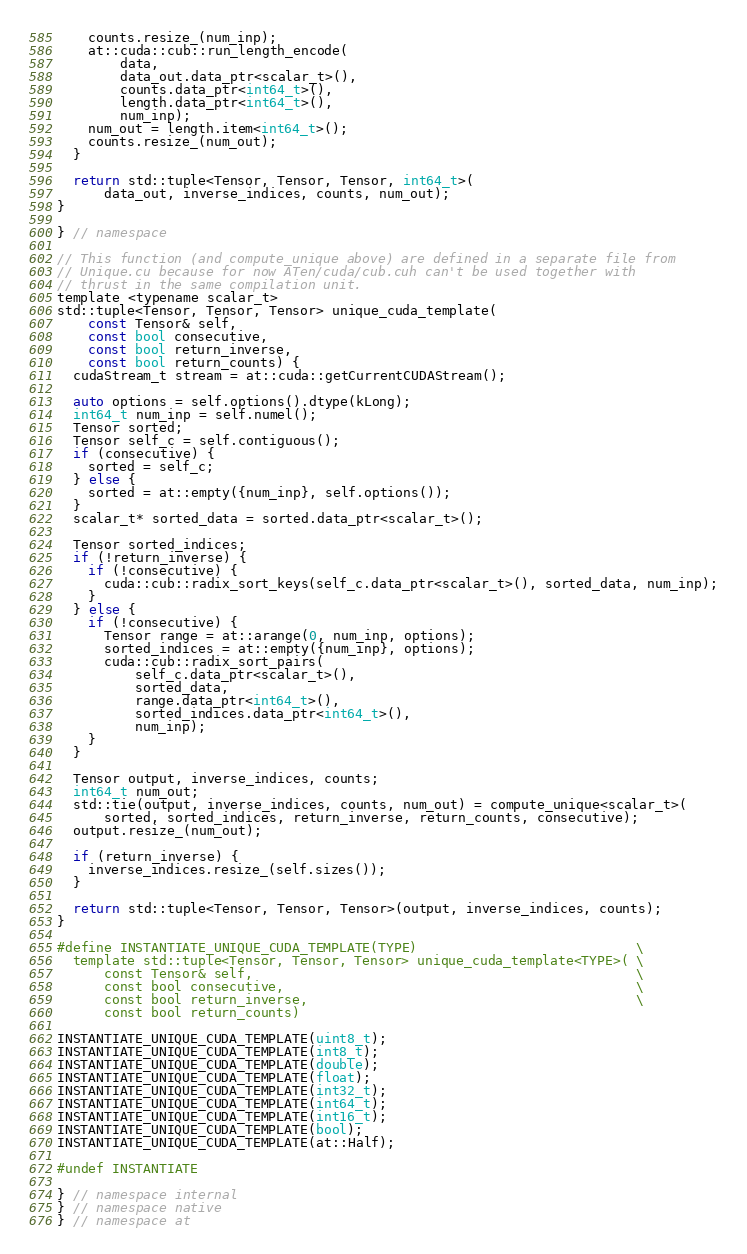Convert code to text. <code><loc_0><loc_0><loc_500><loc_500><_Cuda_>    counts.resize_(num_inp);
    at::cuda::cub::run_length_encode(
        data,
        data_out.data_ptr<scalar_t>(),
        counts.data_ptr<int64_t>(),
        length.data_ptr<int64_t>(),
        num_inp);
    num_out = length.item<int64_t>();
    counts.resize_(num_out);
  }

  return std::tuple<Tensor, Tensor, Tensor, int64_t>(
      data_out, inverse_indices, counts, num_out);
}

} // namespace

// This function (and compute_unique above) are defined in a separate file from
// Unique.cu because for now ATen/cuda/cub.cuh can't be used together with
// thrust in the same compilation unit.
template <typename scalar_t>
std::tuple<Tensor, Tensor, Tensor> unique_cuda_template(
    const Tensor& self,
    const bool consecutive,
    const bool return_inverse,
    const bool return_counts) {
  cudaStream_t stream = at::cuda::getCurrentCUDAStream();

  auto options = self.options().dtype(kLong);
  int64_t num_inp = self.numel();
  Tensor sorted;
  Tensor self_c = self.contiguous();
  if (consecutive) {
    sorted = self_c;
  } else {
    sorted = at::empty({num_inp}, self.options());
  }
  scalar_t* sorted_data = sorted.data_ptr<scalar_t>();

  Tensor sorted_indices;
  if (!return_inverse) {
    if (!consecutive) {
      cuda::cub::radix_sort_keys(self_c.data_ptr<scalar_t>(), sorted_data, num_inp);
    }
  } else {
    if (!consecutive) {
      Tensor range = at::arange(0, num_inp, options);
      sorted_indices = at::empty({num_inp}, options);
      cuda::cub::radix_sort_pairs(
          self_c.data_ptr<scalar_t>(),
          sorted_data,
          range.data_ptr<int64_t>(),
          sorted_indices.data_ptr<int64_t>(),
          num_inp);
    }
  }

  Tensor output, inverse_indices, counts;
  int64_t num_out;
  std::tie(output, inverse_indices, counts, num_out) = compute_unique<scalar_t>(
      sorted, sorted_indices, return_inverse, return_counts, consecutive);
  output.resize_(num_out);

  if (return_inverse) {
    inverse_indices.resize_(self.sizes());
  }

  return std::tuple<Tensor, Tensor, Tensor>(output, inverse_indices, counts);
}

#define INSTANTIATE_UNIQUE_CUDA_TEMPLATE(TYPE)                            \
  template std::tuple<Tensor, Tensor, Tensor> unique_cuda_template<TYPE>( \
      const Tensor& self,                                                 \
      const bool consecutive,                                             \
      const bool return_inverse,                                          \
      const bool return_counts)

INSTANTIATE_UNIQUE_CUDA_TEMPLATE(uint8_t);
INSTANTIATE_UNIQUE_CUDA_TEMPLATE(int8_t);
INSTANTIATE_UNIQUE_CUDA_TEMPLATE(double);
INSTANTIATE_UNIQUE_CUDA_TEMPLATE(float);
INSTANTIATE_UNIQUE_CUDA_TEMPLATE(int32_t);
INSTANTIATE_UNIQUE_CUDA_TEMPLATE(int64_t);
INSTANTIATE_UNIQUE_CUDA_TEMPLATE(int16_t);
INSTANTIATE_UNIQUE_CUDA_TEMPLATE(bool);
INSTANTIATE_UNIQUE_CUDA_TEMPLATE(at::Half);

#undef INSTANTIATE

} // namespace internal
} // namespace native
} // namespace at
</code> 